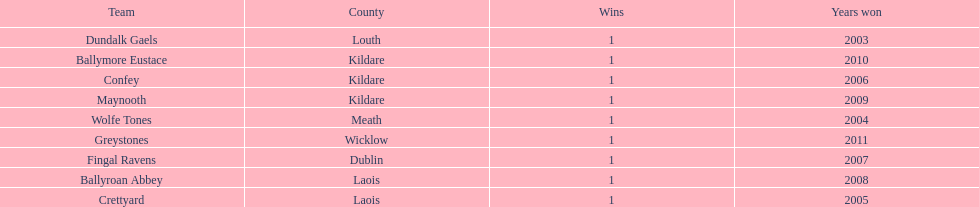How many wins does greystones have? 1. 